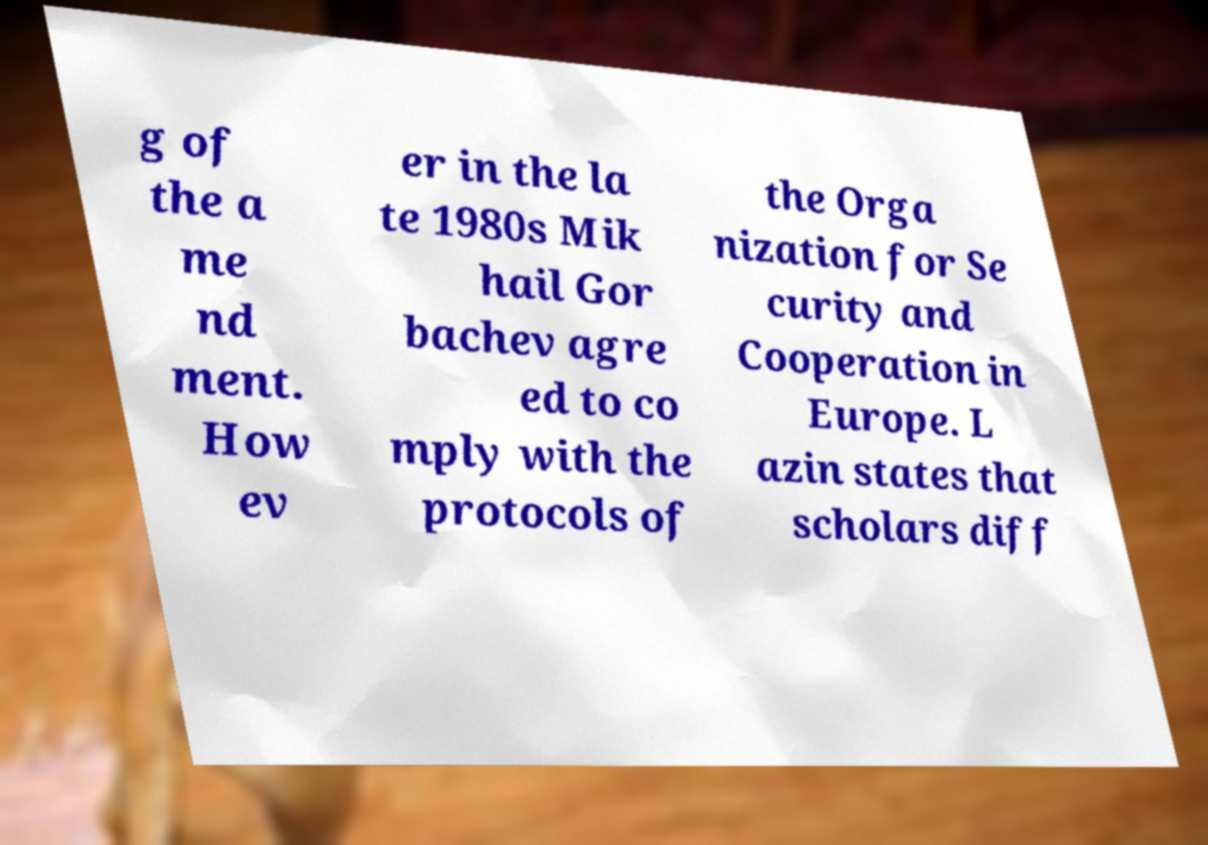Please read and relay the text visible in this image. What does it say? g of the a me nd ment. How ev er in the la te 1980s Mik hail Gor bachev agre ed to co mply with the protocols of the Orga nization for Se curity and Cooperation in Europe. L azin states that scholars diff 